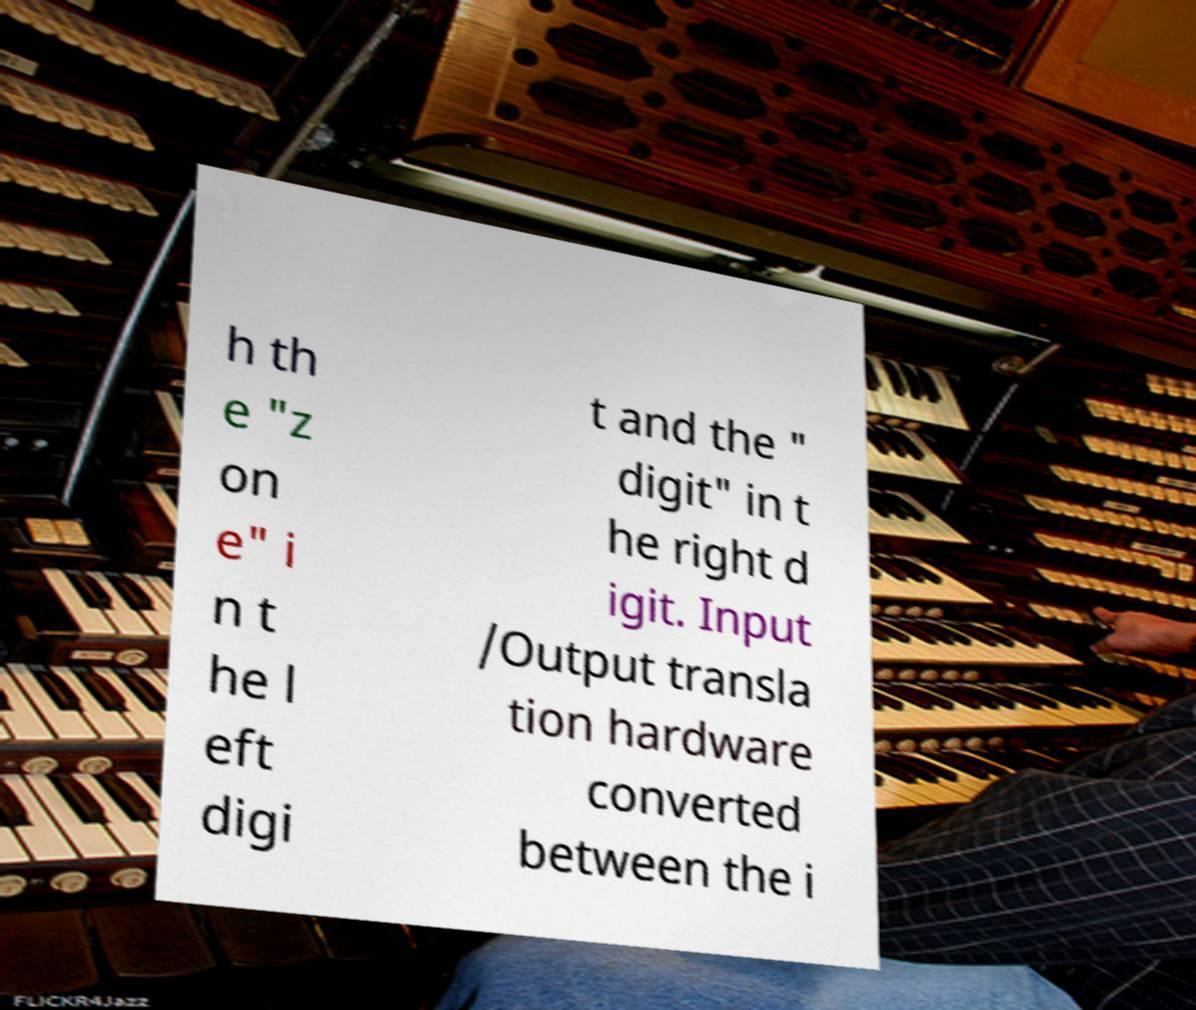For documentation purposes, I need the text within this image transcribed. Could you provide that? h th e "z on e" i n t he l eft digi t and the " digit" in t he right d igit. Input /Output transla tion hardware converted between the i 